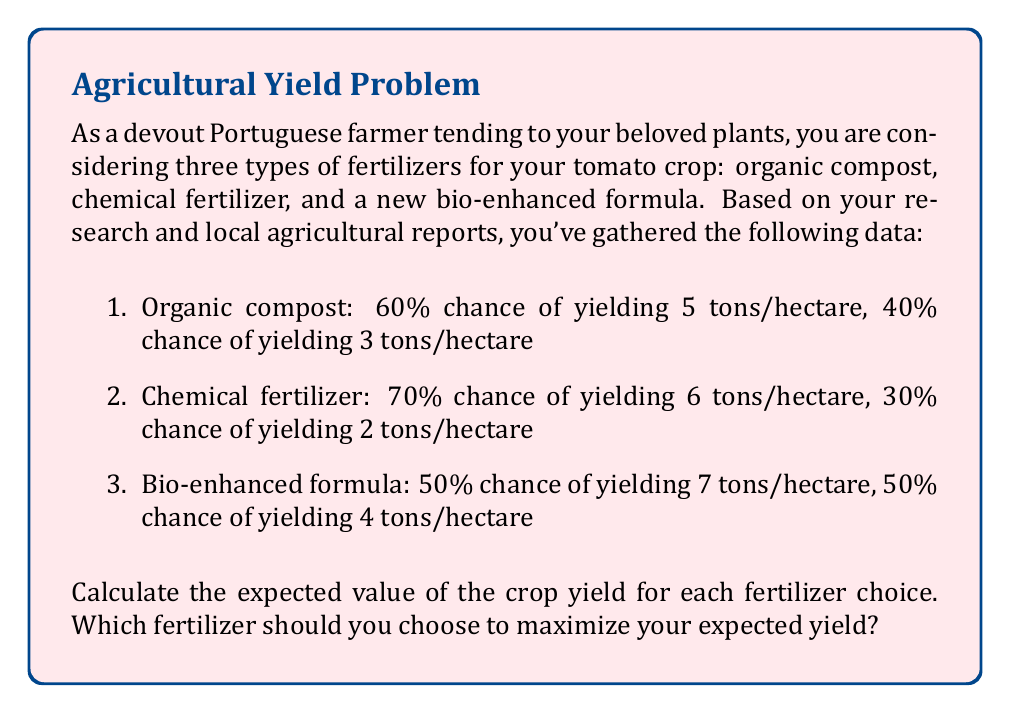Provide a solution to this math problem. To solve this problem, we need to calculate the expected value for each fertilizer option using the formula for expected value:

$$ E(X) = \sum_{i=1}^{n} p_i \cdot x_i $$

Where $E(X)$ is the expected value, $p_i$ is the probability of each outcome, and $x_i$ is the value of each outcome.

Let's calculate the expected value for each fertilizer:

1. Organic compost:
$$ E(X_{organic}) = (0.60 \cdot 5) + (0.40 \cdot 3) = 3 + 1.2 = 4.2 \text{ tons/hectare} $$

2. Chemical fertilizer:
$$ E(X_{chemical}) = (0.70 \cdot 6) + (0.30 \cdot 2) = 4.2 + 0.6 = 4.8 \text{ tons/hectare} $$

3. Bio-enhanced formula:
$$ E(X_{bio}) = (0.50 \cdot 7) + (0.50 \cdot 4) = 3.5 + 2 = 5.5 \text{ tons/hectare} $$

To maximize the expected yield, we should choose the fertilizer with the highest expected value.
Answer: The expected values for each fertilizer are:
1. Organic compost: 4.2 tons/hectare
2. Chemical fertilizer: 4.8 tons/hectare
3. Bio-enhanced formula: 5.5 tons/hectare

To maximize the expected yield, you should choose the bio-enhanced formula, which has the highest expected value of 5.5 tons/hectare. 